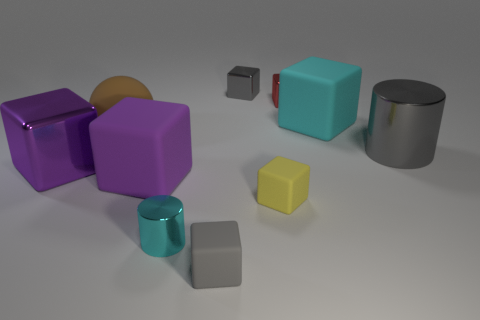Subtract all big purple matte blocks. How many blocks are left? 6 Subtract all yellow cubes. How many cubes are left? 6 Subtract all cyan cubes. Subtract all red cylinders. How many cubes are left? 6 Subtract all cylinders. How many objects are left? 8 Add 1 small cylinders. How many small cylinders are left? 2 Add 8 rubber spheres. How many rubber spheres exist? 9 Subtract 1 cyan blocks. How many objects are left? 9 Subtract all small objects. Subtract all gray matte cubes. How many objects are left? 4 